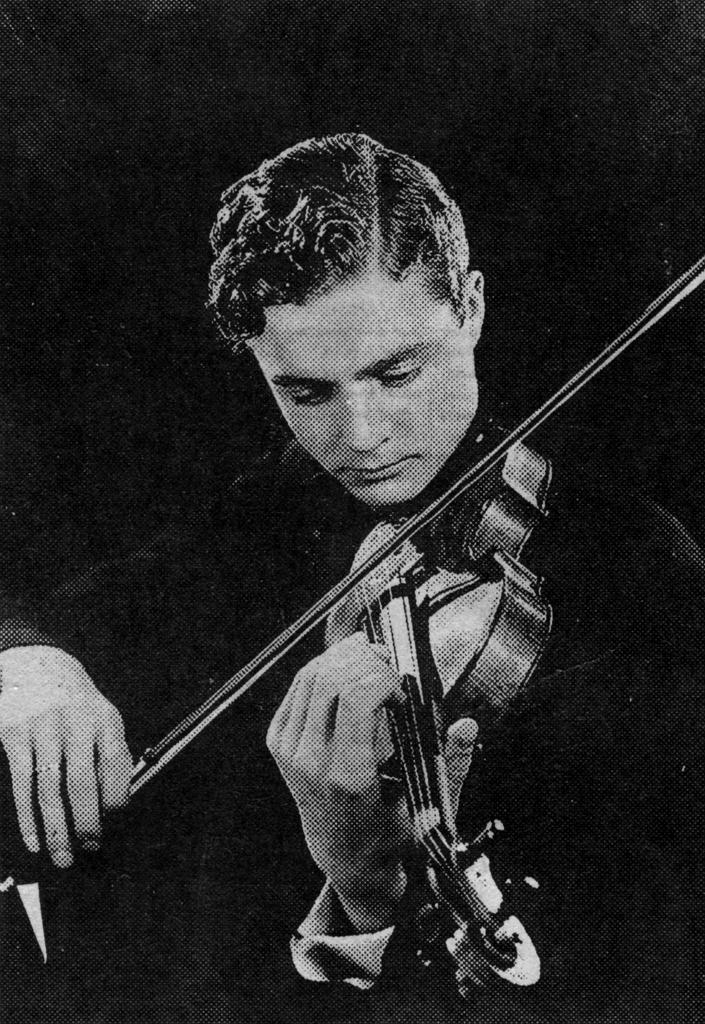What is the main subject of the image? The main subject of the image is a man. What is the man doing in the image? The man is playing a musical instrument in the image. Can you see any doors or playgrounds in the image? No, there are no doors or playgrounds visible in the image. Is the man playing his musical instrument at the zoo in the image? There is no information about the location of the man in the image, so it cannot be determined if he is at the zoo. 